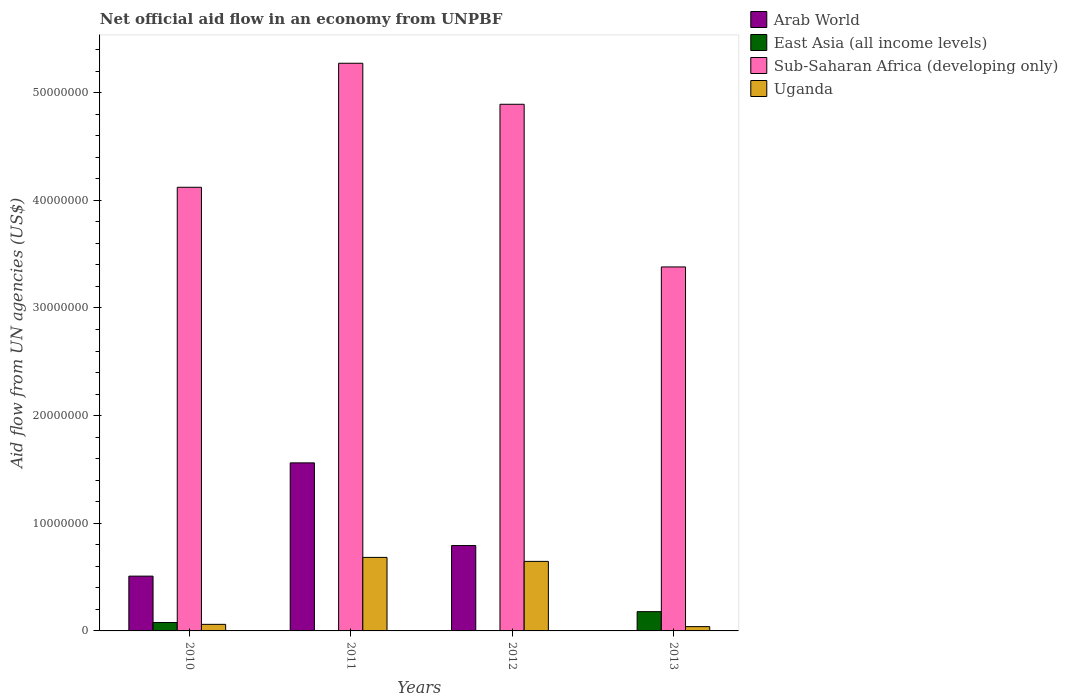Are the number of bars per tick equal to the number of legend labels?
Offer a terse response. No. How many bars are there on the 4th tick from the right?
Your answer should be very brief. 4. What is the label of the 1st group of bars from the left?
Keep it short and to the point. 2010. What is the net official aid flow in East Asia (all income levels) in 2010?
Offer a very short reply. 7.80e+05. Across all years, what is the maximum net official aid flow in Sub-Saharan Africa (developing only)?
Your answer should be compact. 5.27e+07. Across all years, what is the minimum net official aid flow in Sub-Saharan Africa (developing only)?
Offer a terse response. 3.38e+07. What is the total net official aid flow in Arab World in the graph?
Offer a terse response. 2.86e+07. What is the difference between the net official aid flow in Arab World in 2011 and that in 2012?
Your response must be concise. 7.68e+06. What is the average net official aid flow in Sub-Saharan Africa (developing only) per year?
Provide a short and direct response. 4.42e+07. In the year 2011, what is the difference between the net official aid flow in Sub-Saharan Africa (developing only) and net official aid flow in East Asia (all income levels)?
Offer a terse response. 5.27e+07. What is the ratio of the net official aid flow in Uganda in 2011 to that in 2013?
Offer a very short reply. 17.07. Is the net official aid flow in Arab World in 2010 less than that in 2011?
Keep it short and to the point. Yes. Is the difference between the net official aid flow in Sub-Saharan Africa (developing only) in 2012 and 2013 greater than the difference between the net official aid flow in East Asia (all income levels) in 2012 and 2013?
Provide a succinct answer. Yes. What is the difference between the highest and the second highest net official aid flow in Sub-Saharan Africa (developing only)?
Keep it short and to the point. 3.81e+06. What is the difference between the highest and the lowest net official aid flow in East Asia (all income levels)?
Ensure brevity in your answer.  1.78e+06. Is the sum of the net official aid flow in East Asia (all income levels) in 2010 and 2012 greater than the maximum net official aid flow in Arab World across all years?
Ensure brevity in your answer.  No. Is it the case that in every year, the sum of the net official aid flow in Uganda and net official aid flow in Sub-Saharan Africa (developing only) is greater than the sum of net official aid flow in Arab World and net official aid flow in East Asia (all income levels)?
Keep it short and to the point. Yes. Is it the case that in every year, the sum of the net official aid flow in East Asia (all income levels) and net official aid flow in Sub-Saharan Africa (developing only) is greater than the net official aid flow in Uganda?
Keep it short and to the point. Yes. Are all the bars in the graph horizontal?
Give a very brief answer. No. How many years are there in the graph?
Offer a terse response. 4. What is the difference between two consecutive major ticks on the Y-axis?
Provide a short and direct response. 1.00e+07. Are the values on the major ticks of Y-axis written in scientific E-notation?
Give a very brief answer. No. Does the graph contain any zero values?
Your answer should be very brief. Yes. Where does the legend appear in the graph?
Your answer should be compact. Top right. How are the legend labels stacked?
Give a very brief answer. Vertical. What is the title of the graph?
Offer a terse response. Net official aid flow in an economy from UNPBF. Does "Aruba" appear as one of the legend labels in the graph?
Your answer should be compact. No. What is the label or title of the Y-axis?
Offer a terse response. Aid flow from UN agencies (US$). What is the Aid flow from UN agencies (US$) in Arab World in 2010?
Provide a succinct answer. 5.09e+06. What is the Aid flow from UN agencies (US$) of East Asia (all income levels) in 2010?
Make the answer very short. 7.80e+05. What is the Aid flow from UN agencies (US$) of Sub-Saharan Africa (developing only) in 2010?
Your answer should be compact. 4.12e+07. What is the Aid flow from UN agencies (US$) of Uganda in 2010?
Your response must be concise. 6.10e+05. What is the Aid flow from UN agencies (US$) in Arab World in 2011?
Offer a very short reply. 1.56e+07. What is the Aid flow from UN agencies (US$) of Sub-Saharan Africa (developing only) in 2011?
Offer a terse response. 5.27e+07. What is the Aid flow from UN agencies (US$) of Uganda in 2011?
Offer a very short reply. 6.83e+06. What is the Aid flow from UN agencies (US$) in Arab World in 2012?
Offer a terse response. 7.93e+06. What is the Aid flow from UN agencies (US$) in Sub-Saharan Africa (developing only) in 2012?
Make the answer very short. 4.89e+07. What is the Aid flow from UN agencies (US$) in Uganda in 2012?
Provide a short and direct response. 6.46e+06. What is the Aid flow from UN agencies (US$) of Arab World in 2013?
Provide a short and direct response. 0. What is the Aid flow from UN agencies (US$) of East Asia (all income levels) in 2013?
Your response must be concise. 1.79e+06. What is the Aid flow from UN agencies (US$) in Sub-Saharan Africa (developing only) in 2013?
Give a very brief answer. 3.38e+07. Across all years, what is the maximum Aid flow from UN agencies (US$) of Arab World?
Ensure brevity in your answer.  1.56e+07. Across all years, what is the maximum Aid flow from UN agencies (US$) of East Asia (all income levels)?
Give a very brief answer. 1.79e+06. Across all years, what is the maximum Aid flow from UN agencies (US$) in Sub-Saharan Africa (developing only)?
Make the answer very short. 5.27e+07. Across all years, what is the maximum Aid flow from UN agencies (US$) of Uganda?
Give a very brief answer. 6.83e+06. Across all years, what is the minimum Aid flow from UN agencies (US$) of East Asia (all income levels)?
Provide a short and direct response. 10000. Across all years, what is the minimum Aid flow from UN agencies (US$) in Sub-Saharan Africa (developing only)?
Offer a very short reply. 3.38e+07. Across all years, what is the minimum Aid flow from UN agencies (US$) in Uganda?
Keep it short and to the point. 4.00e+05. What is the total Aid flow from UN agencies (US$) of Arab World in the graph?
Your response must be concise. 2.86e+07. What is the total Aid flow from UN agencies (US$) in East Asia (all income levels) in the graph?
Keep it short and to the point. 2.60e+06. What is the total Aid flow from UN agencies (US$) in Sub-Saharan Africa (developing only) in the graph?
Offer a terse response. 1.77e+08. What is the total Aid flow from UN agencies (US$) of Uganda in the graph?
Provide a succinct answer. 1.43e+07. What is the difference between the Aid flow from UN agencies (US$) of Arab World in 2010 and that in 2011?
Offer a very short reply. -1.05e+07. What is the difference between the Aid flow from UN agencies (US$) of East Asia (all income levels) in 2010 and that in 2011?
Your answer should be compact. 7.70e+05. What is the difference between the Aid flow from UN agencies (US$) in Sub-Saharan Africa (developing only) in 2010 and that in 2011?
Your answer should be very brief. -1.15e+07. What is the difference between the Aid flow from UN agencies (US$) in Uganda in 2010 and that in 2011?
Your response must be concise. -6.22e+06. What is the difference between the Aid flow from UN agencies (US$) in Arab World in 2010 and that in 2012?
Provide a succinct answer. -2.84e+06. What is the difference between the Aid flow from UN agencies (US$) of East Asia (all income levels) in 2010 and that in 2012?
Give a very brief answer. 7.60e+05. What is the difference between the Aid flow from UN agencies (US$) of Sub-Saharan Africa (developing only) in 2010 and that in 2012?
Keep it short and to the point. -7.71e+06. What is the difference between the Aid flow from UN agencies (US$) of Uganda in 2010 and that in 2012?
Give a very brief answer. -5.85e+06. What is the difference between the Aid flow from UN agencies (US$) of East Asia (all income levels) in 2010 and that in 2013?
Make the answer very short. -1.01e+06. What is the difference between the Aid flow from UN agencies (US$) of Sub-Saharan Africa (developing only) in 2010 and that in 2013?
Provide a short and direct response. 7.40e+06. What is the difference between the Aid flow from UN agencies (US$) in Uganda in 2010 and that in 2013?
Your response must be concise. 2.10e+05. What is the difference between the Aid flow from UN agencies (US$) in Arab World in 2011 and that in 2012?
Provide a succinct answer. 7.68e+06. What is the difference between the Aid flow from UN agencies (US$) of Sub-Saharan Africa (developing only) in 2011 and that in 2012?
Give a very brief answer. 3.81e+06. What is the difference between the Aid flow from UN agencies (US$) of East Asia (all income levels) in 2011 and that in 2013?
Ensure brevity in your answer.  -1.78e+06. What is the difference between the Aid flow from UN agencies (US$) of Sub-Saharan Africa (developing only) in 2011 and that in 2013?
Offer a very short reply. 1.89e+07. What is the difference between the Aid flow from UN agencies (US$) in Uganda in 2011 and that in 2013?
Your answer should be very brief. 6.43e+06. What is the difference between the Aid flow from UN agencies (US$) in East Asia (all income levels) in 2012 and that in 2013?
Your answer should be compact. -1.77e+06. What is the difference between the Aid flow from UN agencies (US$) of Sub-Saharan Africa (developing only) in 2012 and that in 2013?
Offer a terse response. 1.51e+07. What is the difference between the Aid flow from UN agencies (US$) in Uganda in 2012 and that in 2013?
Your response must be concise. 6.06e+06. What is the difference between the Aid flow from UN agencies (US$) in Arab World in 2010 and the Aid flow from UN agencies (US$) in East Asia (all income levels) in 2011?
Offer a very short reply. 5.08e+06. What is the difference between the Aid flow from UN agencies (US$) in Arab World in 2010 and the Aid flow from UN agencies (US$) in Sub-Saharan Africa (developing only) in 2011?
Offer a terse response. -4.76e+07. What is the difference between the Aid flow from UN agencies (US$) of Arab World in 2010 and the Aid flow from UN agencies (US$) of Uganda in 2011?
Make the answer very short. -1.74e+06. What is the difference between the Aid flow from UN agencies (US$) in East Asia (all income levels) in 2010 and the Aid flow from UN agencies (US$) in Sub-Saharan Africa (developing only) in 2011?
Your response must be concise. -5.20e+07. What is the difference between the Aid flow from UN agencies (US$) of East Asia (all income levels) in 2010 and the Aid flow from UN agencies (US$) of Uganda in 2011?
Make the answer very short. -6.05e+06. What is the difference between the Aid flow from UN agencies (US$) of Sub-Saharan Africa (developing only) in 2010 and the Aid flow from UN agencies (US$) of Uganda in 2011?
Provide a succinct answer. 3.44e+07. What is the difference between the Aid flow from UN agencies (US$) in Arab World in 2010 and the Aid flow from UN agencies (US$) in East Asia (all income levels) in 2012?
Keep it short and to the point. 5.07e+06. What is the difference between the Aid flow from UN agencies (US$) of Arab World in 2010 and the Aid flow from UN agencies (US$) of Sub-Saharan Africa (developing only) in 2012?
Give a very brief answer. -4.38e+07. What is the difference between the Aid flow from UN agencies (US$) of Arab World in 2010 and the Aid flow from UN agencies (US$) of Uganda in 2012?
Your answer should be very brief. -1.37e+06. What is the difference between the Aid flow from UN agencies (US$) in East Asia (all income levels) in 2010 and the Aid flow from UN agencies (US$) in Sub-Saharan Africa (developing only) in 2012?
Provide a short and direct response. -4.81e+07. What is the difference between the Aid flow from UN agencies (US$) in East Asia (all income levels) in 2010 and the Aid flow from UN agencies (US$) in Uganda in 2012?
Your answer should be compact. -5.68e+06. What is the difference between the Aid flow from UN agencies (US$) of Sub-Saharan Africa (developing only) in 2010 and the Aid flow from UN agencies (US$) of Uganda in 2012?
Ensure brevity in your answer.  3.48e+07. What is the difference between the Aid flow from UN agencies (US$) in Arab World in 2010 and the Aid flow from UN agencies (US$) in East Asia (all income levels) in 2013?
Make the answer very short. 3.30e+06. What is the difference between the Aid flow from UN agencies (US$) in Arab World in 2010 and the Aid flow from UN agencies (US$) in Sub-Saharan Africa (developing only) in 2013?
Your response must be concise. -2.87e+07. What is the difference between the Aid flow from UN agencies (US$) of Arab World in 2010 and the Aid flow from UN agencies (US$) of Uganda in 2013?
Make the answer very short. 4.69e+06. What is the difference between the Aid flow from UN agencies (US$) of East Asia (all income levels) in 2010 and the Aid flow from UN agencies (US$) of Sub-Saharan Africa (developing only) in 2013?
Your response must be concise. -3.30e+07. What is the difference between the Aid flow from UN agencies (US$) in East Asia (all income levels) in 2010 and the Aid flow from UN agencies (US$) in Uganda in 2013?
Keep it short and to the point. 3.80e+05. What is the difference between the Aid flow from UN agencies (US$) in Sub-Saharan Africa (developing only) in 2010 and the Aid flow from UN agencies (US$) in Uganda in 2013?
Provide a short and direct response. 4.08e+07. What is the difference between the Aid flow from UN agencies (US$) in Arab World in 2011 and the Aid flow from UN agencies (US$) in East Asia (all income levels) in 2012?
Your answer should be compact. 1.56e+07. What is the difference between the Aid flow from UN agencies (US$) of Arab World in 2011 and the Aid flow from UN agencies (US$) of Sub-Saharan Africa (developing only) in 2012?
Give a very brief answer. -3.33e+07. What is the difference between the Aid flow from UN agencies (US$) of Arab World in 2011 and the Aid flow from UN agencies (US$) of Uganda in 2012?
Provide a short and direct response. 9.15e+06. What is the difference between the Aid flow from UN agencies (US$) of East Asia (all income levels) in 2011 and the Aid flow from UN agencies (US$) of Sub-Saharan Africa (developing only) in 2012?
Your response must be concise. -4.89e+07. What is the difference between the Aid flow from UN agencies (US$) of East Asia (all income levels) in 2011 and the Aid flow from UN agencies (US$) of Uganda in 2012?
Give a very brief answer. -6.45e+06. What is the difference between the Aid flow from UN agencies (US$) of Sub-Saharan Africa (developing only) in 2011 and the Aid flow from UN agencies (US$) of Uganda in 2012?
Offer a very short reply. 4.63e+07. What is the difference between the Aid flow from UN agencies (US$) in Arab World in 2011 and the Aid flow from UN agencies (US$) in East Asia (all income levels) in 2013?
Give a very brief answer. 1.38e+07. What is the difference between the Aid flow from UN agencies (US$) of Arab World in 2011 and the Aid flow from UN agencies (US$) of Sub-Saharan Africa (developing only) in 2013?
Offer a very short reply. -1.82e+07. What is the difference between the Aid flow from UN agencies (US$) of Arab World in 2011 and the Aid flow from UN agencies (US$) of Uganda in 2013?
Ensure brevity in your answer.  1.52e+07. What is the difference between the Aid flow from UN agencies (US$) in East Asia (all income levels) in 2011 and the Aid flow from UN agencies (US$) in Sub-Saharan Africa (developing only) in 2013?
Provide a succinct answer. -3.38e+07. What is the difference between the Aid flow from UN agencies (US$) in East Asia (all income levels) in 2011 and the Aid flow from UN agencies (US$) in Uganda in 2013?
Offer a terse response. -3.90e+05. What is the difference between the Aid flow from UN agencies (US$) of Sub-Saharan Africa (developing only) in 2011 and the Aid flow from UN agencies (US$) of Uganda in 2013?
Provide a short and direct response. 5.23e+07. What is the difference between the Aid flow from UN agencies (US$) in Arab World in 2012 and the Aid flow from UN agencies (US$) in East Asia (all income levels) in 2013?
Keep it short and to the point. 6.14e+06. What is the difference between the Aid flow from UN agencies (US$) of Arab World in 2012 and the Aid flow from UN agencies (US$) of Sub-Saharan Africa (developing only) in 2013?
Give a very brief answer. -2.59e+07. What is the difference between the Aid flow from UN agencies (US$) of Arab World in 2012 and the Aid flow from UN agencies (US$) of Uganda in 2013?
Make the answer very short. 7.53e+06. What is the difference between the Aid flow from UN agencies (US$) of East Asia (all income levels) in 2012 and the Aid flow from UN agencies (US$) of Sub-Saharan Africa (developing only) in 2013?
Your answer should be compact. -3.38e+07. What is the difference between the Aid flow from UN agencies (US$) in East Asia (all income levels) in 2012 and the Aid flow from UN agencies (US$) in Uganda in 2013?
Your answer should be compact. -3.80e+05. What is the difference between the Aid flow from UN agencies (US$) of Sub-Saharan Africa (developing only) in 2012 and the Aid flow from UN agencies (US$) of Uganda in 2013?
Provide a short and direct response. 4.85e+07. What is the average Aid flow from UN agencies (US$) in Arab World per year?
Make the answer very short. 7.16e+06. What is the average Aid flow from UN agencies (US$) of East Asia (all income levels) per year?
Offer a terse response. 6.50e+05. What is the average Aid flow from UN agencies (US$) of Sub-Saharan Africa (developing only) per year?
Give a very brief answer. 4.42e+07. What is the average Aid flow from UN agencies (US$) in Uganda per year?
Make the answer very short. 3.58e+06. In the year 2010, what is the difference between the Aid flow from UN agencies (US$) in Arab World and Aid flow from UN agencies (US$) in East Asia (all income levels)?
Give a very brief answer. 4.31e+06. In the year 2010, what is the difference between the Aid flow from UN agencies (US$) in Arab World and Aid flow from UN agencies (US$) in Sub-Saharan Africa (developing only)?
Make the answer very short. -3.61e+07. In the year 2010, what is the difference between the Aid flow from UN agencies (US$) of Arab World and Aid flow from UN agencies (US$) of Uganda?
Ensure brevity in your answer.  4.48e+06. In the year 2010, what is the difference between the Aid flow from UN agencies (US$) in East Asia (all income levels) and Aid flow from UN agencies (US$) in Sub-Saharan Africa (developing only)?
Make the answer very short. -4.04e+07. In the year 2010, what is the difference between the Aid flow from UN agencies (US$) in East Asia (all income levels) and Aid flow from UN agencies (US$) in Uganda?
Provide a succinct answer. 1.70e+05. In the year 2010, what is the difference between the Aid flow from UN agencies (US$) of Sub-Saharan Africa (developing only) and Aid flow from UN agencies (US$) of Uganda?
Your answer should be very brief. 4.06e+07. In the year 2011, what is the difference between the Aid flow from UN agencies (US$) in Arab World and Aid flow from UN agencies (US$) in East Asia (all income levels)?
Make the answer very short. 1.56e+07. In the year 2011, what is the difference between the Aid flow from UN agencies (US$) of Arab World and Aid flow from UN agencies (US$) of Sub-Saharan Africa (developing only)?
Ensure brevity in your answer.  -3.71e+07. In the year 2011, what is the difference between the Aid flow from UN agencies (US$) in Arab World and Aid flow from UN agencies (US$) in Uganda?
Offer a very short reply. 8.78e+06. In the year 2011, what is the difference between the Aid flow from UN agencies (US$) of East Asia (all income levels) and Aid flow from UN agencies (US$) of Sub-Saharan Africa (developing only)?
Keep it short and to the point. -5.27e+07. In the year 2011, what is the difference between the Aid flow from UN agencies (US$) of East Asia (all income levels) and Aid flow from UN agencies (US$) of Uganda?
Your response must be concise. -6.82e+06. In the year 2011, what is the difference between the Aid flow from UN agencies (US$) of Sub-Saharan Africa (developing only) and Aid flow from UN agencies (US$) of Uganda?
Provide a short and direct response. 4.59e+07. In the year 2012, what is the difference between the Aid flow from UN agencies (US$) of Arab World and Aid flow from UN agencies (US$) of East Asia (all income levels)?
Keep it short and to the point. 7.91e+06. In the year 2012, what is the difference between the Aid flow from UN agencies (US$) in Arab World and Aid flow from UN agencies (US$) in Sub-Saharan Africa (developing only)?
Offer a terse response. -4.10e+07. In the year 2012, what is the difference between the Aid flow from UN agencies (US$) of Arab World and Aid flow from UN agencies (US$) of Uganda?
Keep it short and to the point. 1.47e+06. In the year 2012, what is the difference between the Aid flow from UN agencies (US$) of East Asia (all income levels) and Aid flow from UN agencies (US$) of Sub-Saharan Africa (developing only)?
Offer a very short reply. -4.89e+07. In the year 2012, what is the difference between the Aid flow from UN agencies (US$) in East Asia (all income levels) and Aid flow from UN agencies (US$) in Uganda?
Give a very brief answer. -6.44e+06. In the year 2012, what is the difference between the Aid flow from UN agencies (US$) of Sub-Saharan Africa (developing only) and Aid flow from UN agencies (US$) of Uganda?
Keep it short and to the point. 4.25e+07. In the year 2013, what is the difference between the Aid flow from UN agencies (US$) in East Asia (all income levels) and Aid flow from UN agencies (US$) in Sub-Saharan Africa (developing only)?
Your answer should be compact. -3.20e+07. In the year 2013, what is the difference between the Aid flow from UN agencies (US$) in East Asia (all income levels) and Aid flow from UN agencies (US$) in Uganda?
Provide a short and direct response. 1.39e+06. In the year 2013, what is the difference between the Aid flow from UN agencies (US$) in Sub-Saharan Africa (developing only) and Aid flow from UN agencies (US$) in Uganda?
Your answer should be compact. 3.34e+07. What is the ratio of the Aid flow from UN agencies (US$) in Arab World in 2010 to that in 2011?
Your response must be concise. 0.33. What is the ratio of the Aid flow from UN agencies (US$) in Sub-Saharan Africa (developing only) in 2010 to that in 2011?
Offer a terse response. 0.78. What is the ratio of the Aid flow from UN agencies (US$) in Uganda in 2010 to that in 2011?
Offer a very short reply. 0.09. What is the ratio of the Aid flow from UN agencies (US$) in Arab World in 2010 to that in 2012?
Your answer should be compact. 0.64. What is the ratio of the Aid flow from UN agencies (US$) of East Asia (all income levels) in 2010 to that in 2012?
Keep it short and to the point. 39. What is the ratio of the Aid flow from UN agencies (US$) of Sub-Saharan Africa (developing only) in 2010 to that in 2012?
Provide a succinct answer. 0.84. What is the ratio of the Aid flow from UN agencies (US$) in Uganda in 2010 to that in 2012?
Provide a short and direct response. 0.09. What is the ratio of the Aid flow from UN agencies (US$) of East Asia (all income levels) in 2010 to that in 2013?
Make the answer very short. 0.44. What is the ratio of the Aid flow from UN agencies (US$) of Sub-Saharan Africa (developing only) in 2010 to that in 2013?
Your answer should be compact. 1.22. What is the ratio of the Aid flow from UN agencies (US$) in Uganda in 2010 to that in 2013?
Your response must be concise. 1.52. What is the ratio of the Aid flow from UN agencies (US$) in Arab World in 2011 to that in 2012?
Your response must be concise. 1.97. What is the ratio of the Aid flow from UN agencies (US$) in Sub-Saharan Africa (developing only) in 2011 to that in 2012?
Ensure brevity in your answer.  1.08. What is the ratio of the Aid flow from UN agencies (US$) of Uganda in 2011 to that in 2012?
Your answer should be compact. 1.06. What is the ratio of the Aid flow from UN agencies (US$) in East Asia (all income levels) in 2011 to that in 2013?
Your response must be concise. 0.01. What is the ratio of the Aid flow from UN agencies (US$) in Sub-Saharan Africa (developing only) in 2011 to that in 2013?
Provide a short and direct response. 1.56. What is the ratio of the Aid flow from UN agencies (US$) of Uganda in 2011 to that in 2013?
Keep it short and to the point. 17.07. What is the ratio of the Aid flow from UN agencies (US$) in East Asia (all income levels) in 2012 to that in 2013?
Your answer should be compact. 0.01. What is the ratio of the Aid flow from UN agencies (US$) in Sub-Saharan Africa (developing only) in 2012 to that in 2013?
Your answer should be very brief. 1.45. What is the ratio of the Aid flow from UN agencies (US$) in Uganda in 2012 to that in 2013?
Offer a terse response. 16.15. What is the difference between the highest and the second highest Aid flow from UN agencies (US$) in Arab World?
Your response must be concise. 7.68e+06. What is the difference between the highest and the second highest Aid flow from UN agencies (US$) in East Asia (all income levels)?
Ensure brevity in your answer.  1.01e+06. What is the difference between the highest and the second highest Aid flow from UN agencies (US$) in Sub-Saharan Africa (developing only)?
Offer a terse response. 3.81e+06. What is the difference between the highest and the lowest Aid flow from UN agencies (US$) in Arab World?
Make the answer very short. 1.56e+07. What is the difference between the highest and the lowest Aid flow from UN agencies (US$) of East Asia (all income levels)?
Give a very brief answer. 1.78e+06. What is the difference between the highest and the lowest Aid flow from UN agencies (US$) of Sub-Saharan Africa (developing only)?
Your response must be concise. 1.89e+07. What is the difference between the highest and the lowest Aid flow from UN agencies (US$) of Uganda?
Your answer should be very brief. 6.43e+06. 